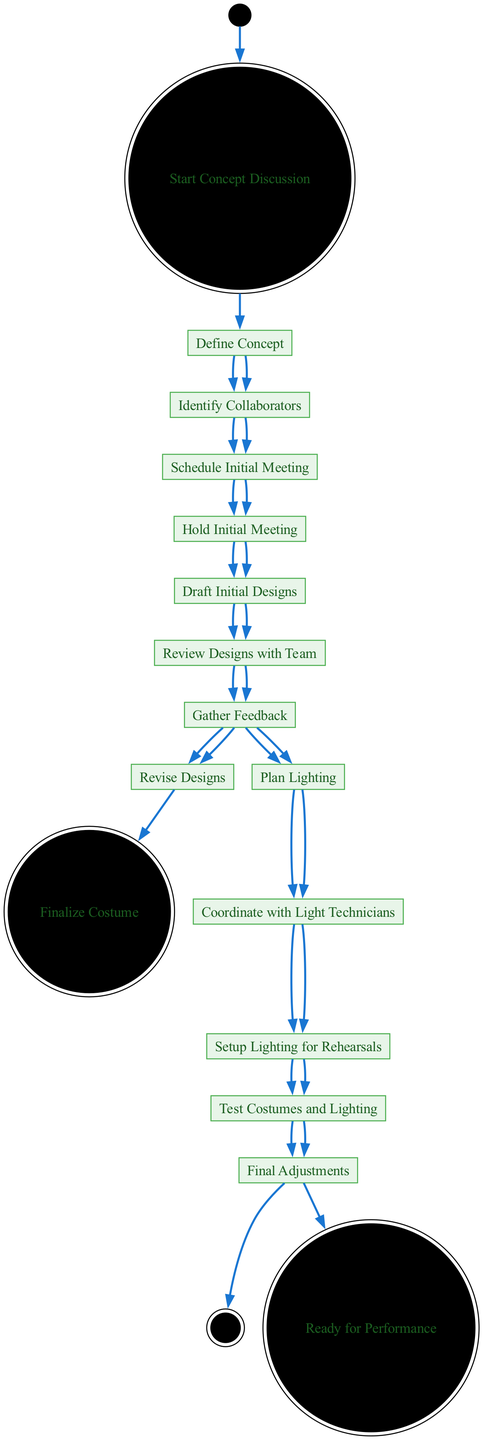What is the initial node of the diagram? The initial node is the starting point of the process, which is labeled "Start Concept Discussion."
Answer: Start Concept Discussion How many total activities are there in the diagram? By counting each activity listed individually from "Define Concept" to "Finalize Costume," we find there are 10 activities in total.
Answer: 10 What is the outgoing node from "Hold Initial Meeting"? "Hold Initial Meeting" leads directly to "Draft Initial Designs," which indicates it is the subsequent step in the process.
Answer: Draft Initial Designs Which activity directly follows "Gather Feedback"? The diagram shows that "Gather Feedback" has two outgoing options: "Revise Designs" and "Plan Lighting." Thus, either activity can follow, but focusing on the next immediate step after gathering feedback typically leads to revision.
Answer: Revise Designs What is the last activity before reaching the final node? The last activity before "Ready for Performance" is "Final Adjustments," which is critical as it prepares all elements for the performance.
Answer: Final Adjustments What step involves collaboration with light technicians? "Coordinate with Light Technicians" occurs after "Plan Lighting," indicating a collaboration requirement to ensure lighting aligns with the overall performance needs.
Answer: Coordinate with Light Technicians Which activity does not lead to Finalize Costume? The activity "Plan Lighting" does not lead to "Finalize Costume," but instead to "Coordinate with Light Technicians." This shows that planning lighting is ancillary to finalizing costume design.
Answer: Plan Lighting What activity leads to gathering feedback? The process of gathering feedback directly follows "Review Designs with Team," indicating that the designs have been discussed and are ready for collective input.
Answer: Review Designs with Team How many outgoing nodes are there from "Draft Initial Designs"? "Draft Initial Designs" has one outgoing node, which is "Review Designs with Team," consolidating the step's singular purpose in progression.
Answer: 1 